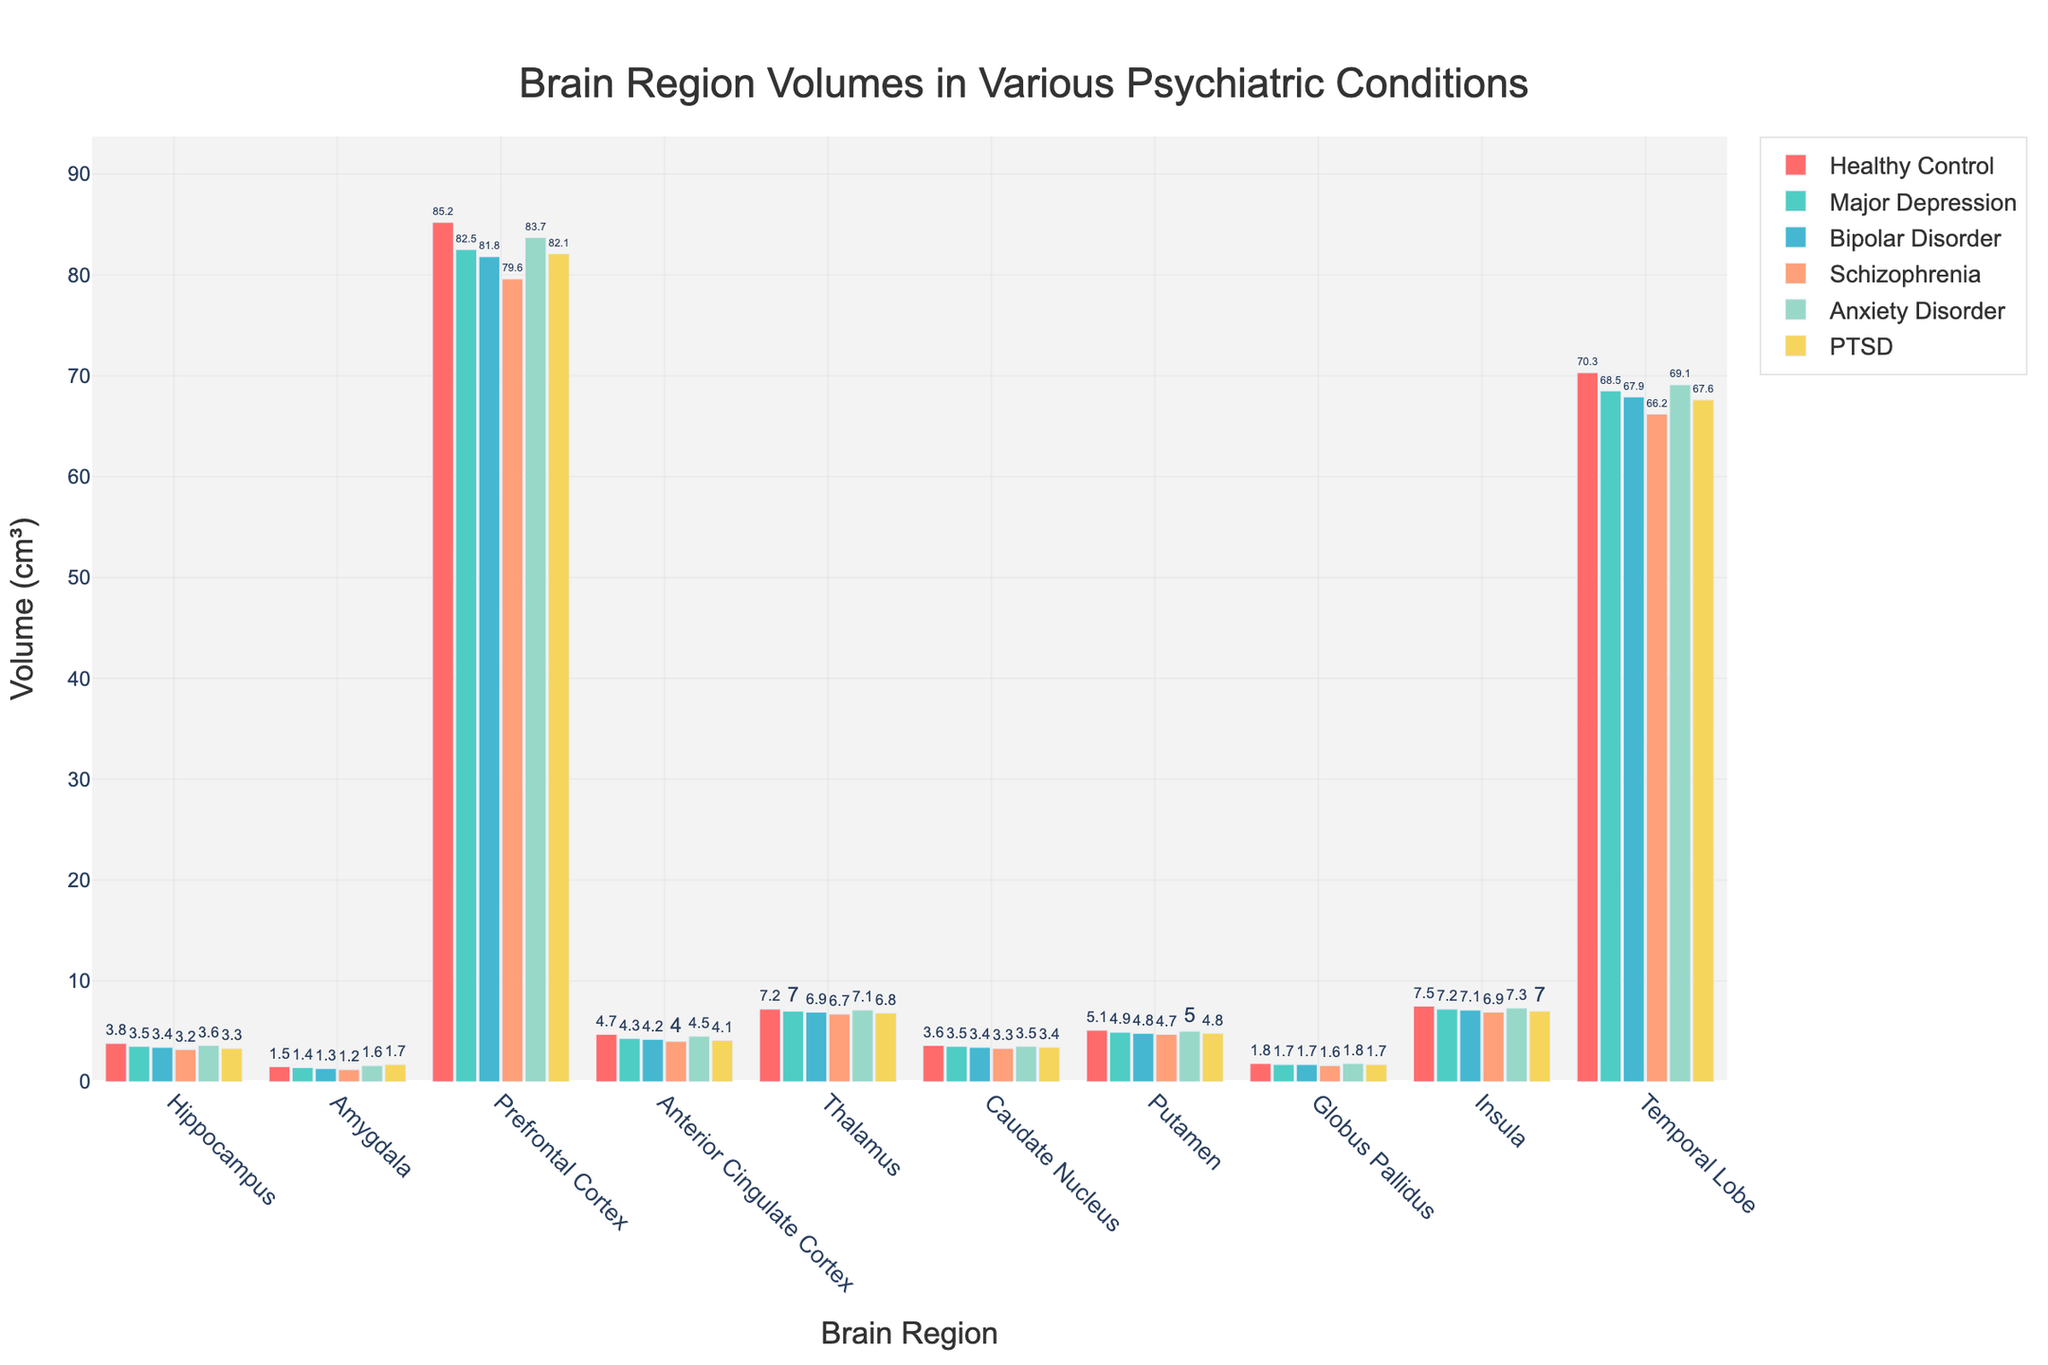Which brain region has the smallest volume in patients with Schizophrenia? Locate the bars corresponding to Schizophrenia and observe their heights to identify the smallest one. It is the amygdala with a volume of 1.2 cm³.
Answer: Amygdala What is the difference in hippocampal volume between healthy controls and patients with Major Depression? Check the height of the bar for the hippocampus under healthy controls (3.8 cm³) and under Major Depression (3.5 cm³), then calculate the difference as 3.8 - 3.5.
Answer: 0.3 cm³ In which psychiatric condition is the amygdala volume the highest? Find the amygdala bars and compare their heights across the different conditions. The highest bar belongs to PTSD with a volume of 1.7 cm³.
Answer: PTSD What is the average volume of the Prefrontal Cortex in patients with Bipolar Disorder and Anxiety Disorder? Find the Prefrontal Cortex bars for Bipolar Disorder (81.8 cm³) and Anxiety Disorder (83.7 cm³), sum them up and divide by 2. The calculation is (81.8 + 83.7) / 2.
Answer: 82.75 cm³ Which brain region shows the most significant volume reduction in Schizophrenia compared to healthy controls? Calculate the volume difference for each brain region between Schizophrenia and healthy controls and find the largest difference. The temporal lobe has the most significant reduction from 70.3 cm³ to 66.2 cm³, a decrease of 4.1 cm³.
Answer: Temporal Lobe How does the volume of the thalamus in Anxiety Disorder compare to that in Major Depression? Compare the heights of the thalamus bars for Anxiety Disorder (7.1 cm³) and Major Depression (7.0 cm³) to see that 7.1 is slightly higher than 7.0.
Answer: 7.1 cm³ is higher What is the combined volume of the Anterior Cingulate Cortex and Insula in patients with PTSD? Add the volume of the Anterior Cingulate Cortex (4.1 cm³) to that of the Insula (7.0 cm³) for PTSD. The combined volume calculation is 4.1 + 7.0.
Answer: 11.1 cm³ 